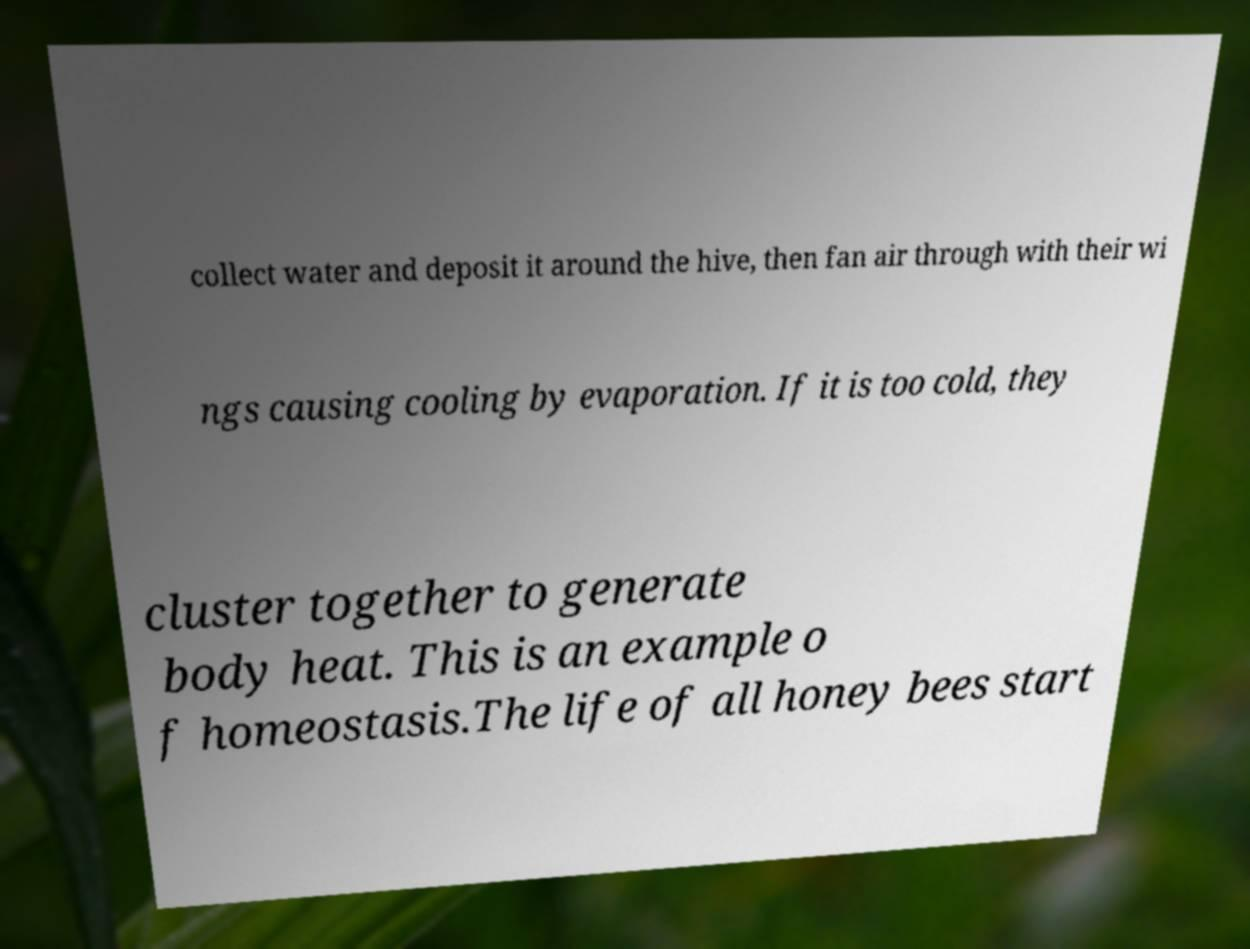I need the written content from this picture converted into text. Can you do that? collect water and deposit it around the hive, then fan air through with their wi ngs causing cooling by evaporation. If it is too cold, they cluster together to generate body heat. This is an example o f homeostasis.The life of all honey bees start 